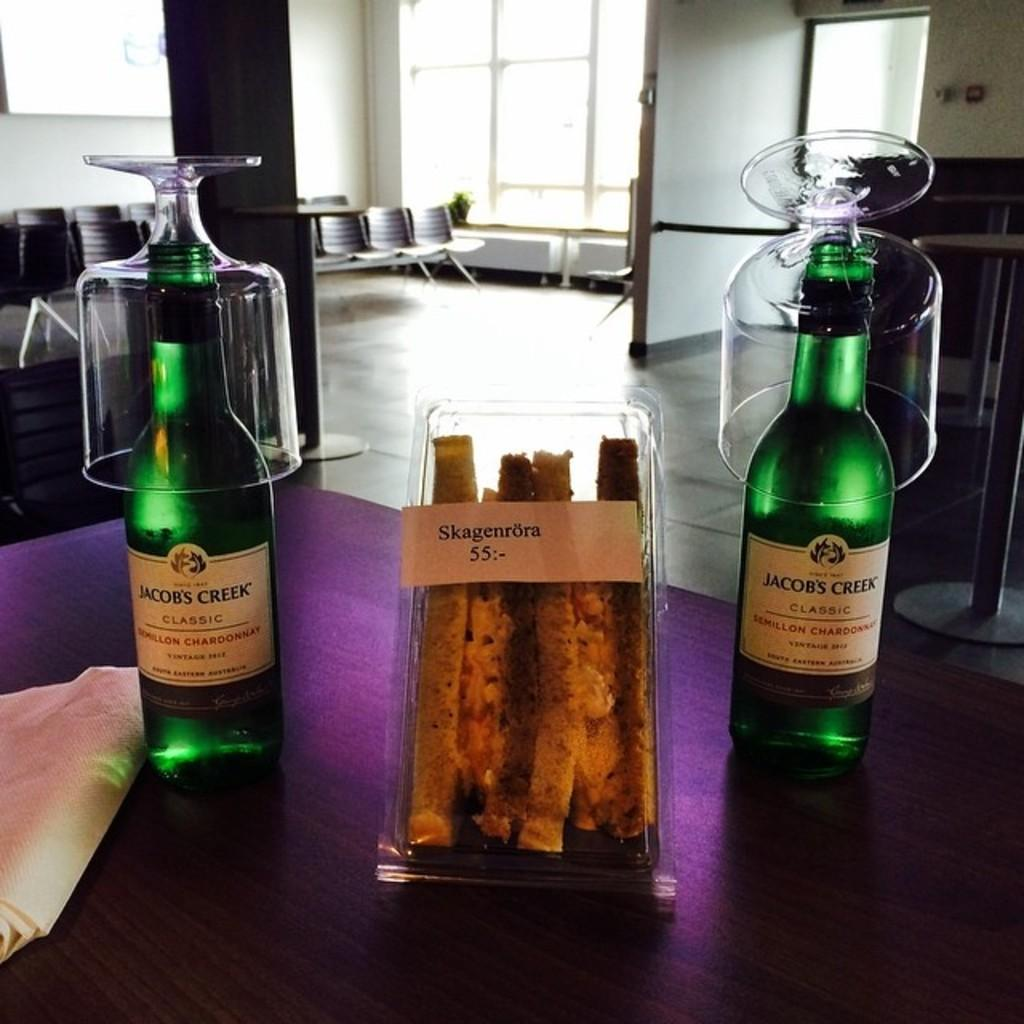<image>
Create a compact narrative representing the image presented. Two bottles of Jacob's Creek with a sandwich in between. 